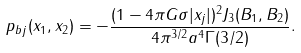Convert formula to latex. <formula><loc_0><loc_0><loc_500><loc_500>p _ { b j } ( x _ { 1 } , x _ { 2 } ) = - \frac { ( 1 - 4 \pi G \sigma | x _ { j } | ) ^ { 2 } J _ { 3 } ( B _ { 1 } , B _ { 2 } ) } { 4 \pi ^ { 3 / 2 } a ^ { 4 } \Gamma ( 3 / 2 ) } .</formula> 